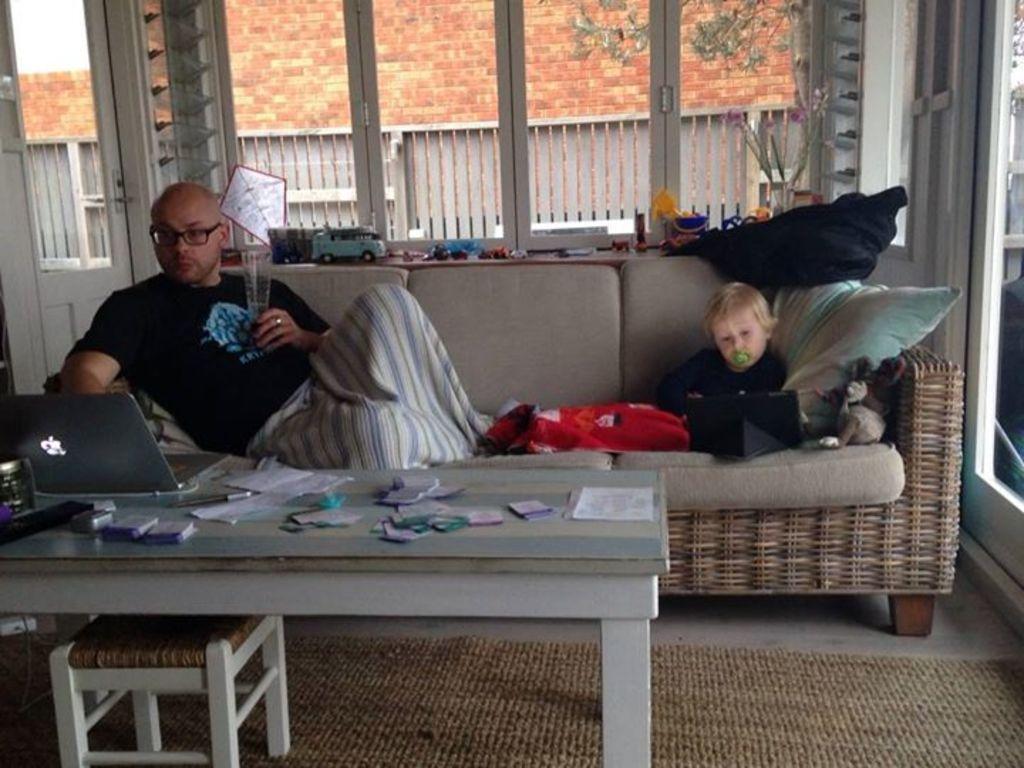How would you summarize this image in a sentence or two? in this image the person is sitting on the sofa and working on the laptop and one boy is also sitting on the sofa behind the person some table is there there are some toys are there on the table and on other table there are laptop,some papers and one more small is also there and the background is cloudy. 